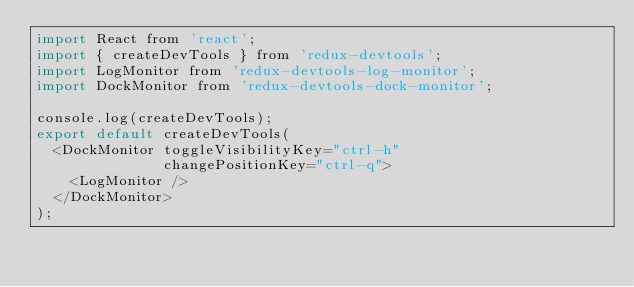<code> <loc_0><loc_0><loc_500><loc_500><_JavaScript_>import React from 'react';
import { createDevTools } from 'redux-devtools';
import LogMonitor from 'redux-devtools-log-monitor';
import DockMonitor from 'redux-devtools-dock-monitor';

console.log(createDevTools);
export default createDevTools(
  <DockMonitor toggleVisibilityKey="ctrl-h"
               changePositionKey="ctrl-q">
    <LogMonitor />
  </DockMonitor>
);
</code> 